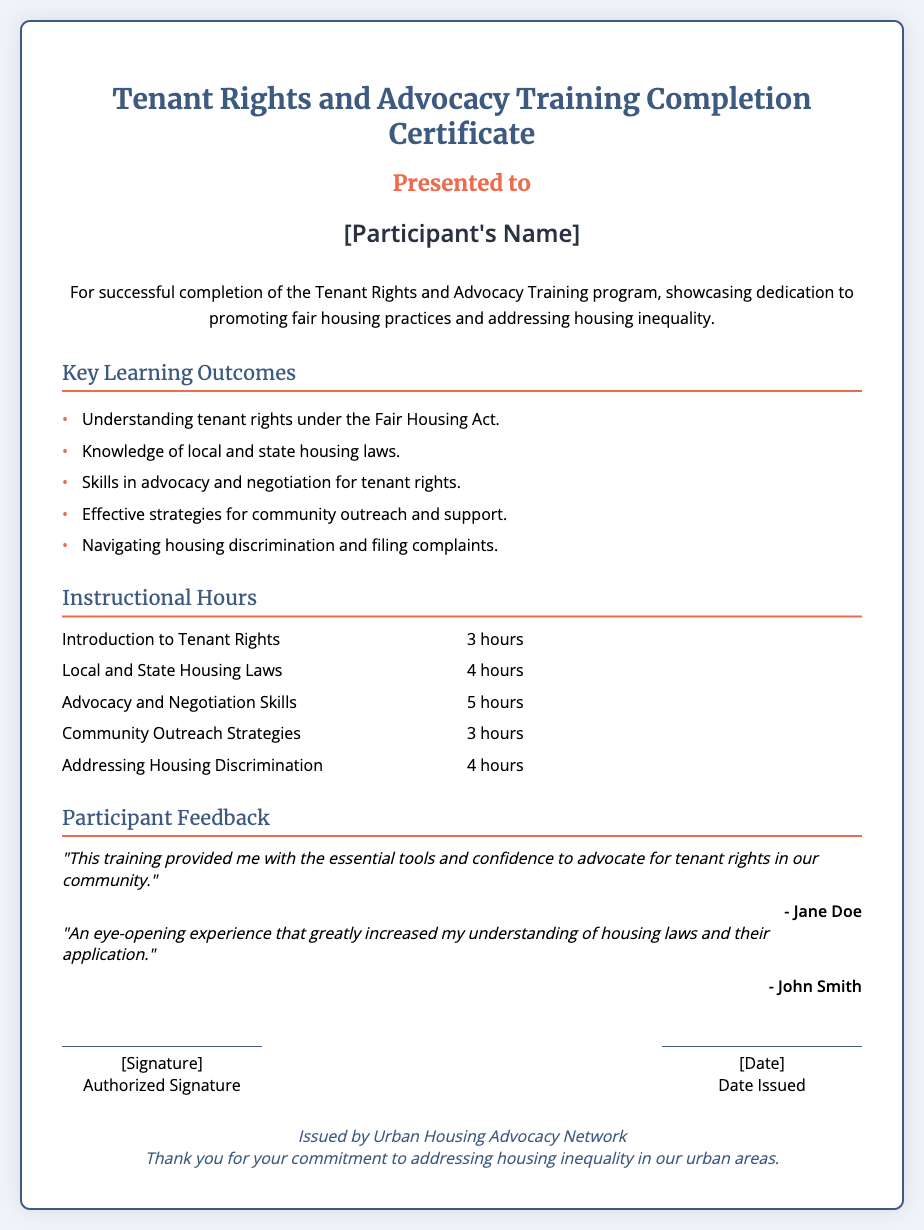what is the title of the document? The title of the document can be found at the top and indicates its purpose.
Answer: Tenant Rights and Advocacy Training Completion Certificate who is the certificate presented to? The name of the participant is indicated in the document.
Answer: [Participant's Name] how many total instructional hours are listed? The instructional hours can be calculated by summing up the hours for each section provided in the hours grid.
Answer: 19 hours what is one key learning outcome mentioned? The document provides specific outcomes in a listed format.
Answer: Understanding tenant rights under the Fair Housing Act who gave feedback stating, "This training provided me with the essential tools and confidence to advocate for tenant rights in our community."? The feedback section identifies who provided each comment.
Answer: Jane Doe how many hours are allocated for Advocacy and Negotiation Skills? The document provides the number of hours explicitly next to the category.
Answer: 5 hours what organization issued this certificate? The footer of the document includes the name of the issuing organization.
Answer: Urban Housing Advocacy Network what does the document indicate is one strategy for outreach? Strategies for outreach can be found in the key learning outcomes section of the document.
Answer: Effective strategies for community outreach and support 